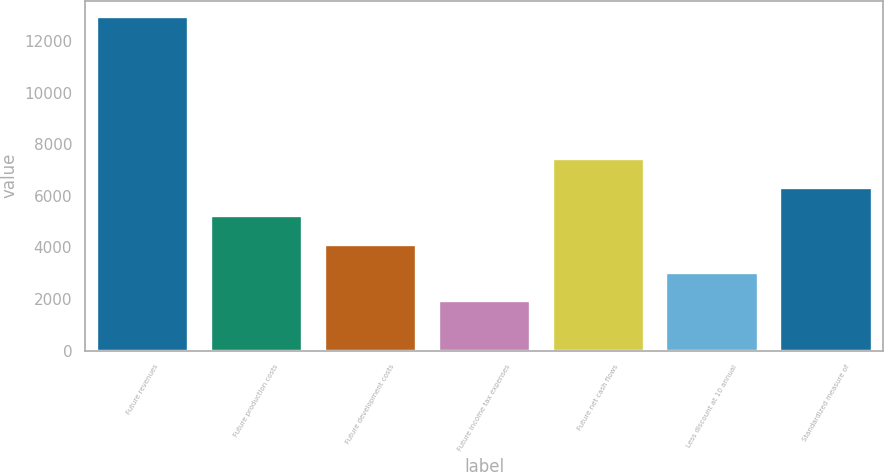Convert chart. <chart><loc_0><loc_0><loc_500><loc_500><bar_chart><fcel>Future revenues<fcel>Future production costs<fcel>Future development costs<fcel>Future income tax expenses<fcel>Future net cash flows<fcel>Less discount at 10 annual<fcel>Standardized measure of<nl><fcel>12917<fcel>5211.4<fcel>4110.6<fcel>1909<fcel>7413<fcel>3009.8<fcel>6312.2<nl></chart> 